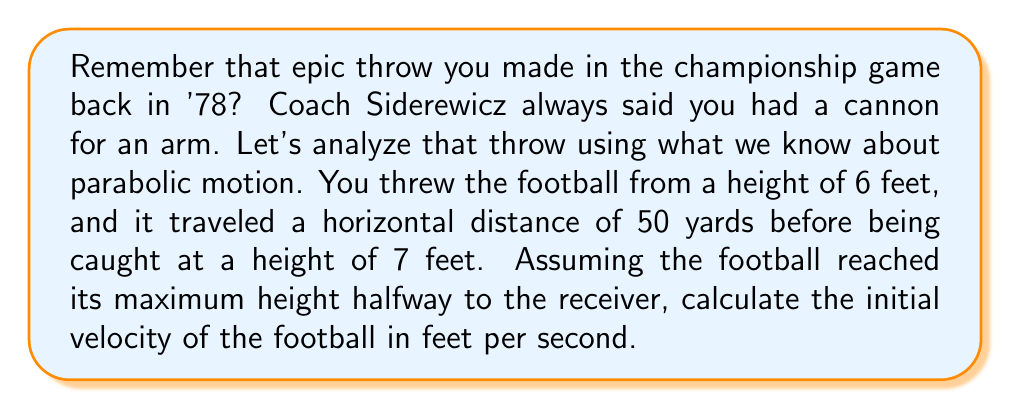Provide a solution to this math problem. Let's approach this step-by-step using the parabolic equation for projectile motion:

1) The general form of a parabola is:
   $$y = ax^2 + bx + c$$

2) Given:
   - Initial height (c) = 6 feet
   - Final height = 7 feet
   - Horizontal distance = 50 yards = 150 feet
   - Max height occurs at x = 75 feet (halfway)

3) We can set up three equations:
   - At x = 0: $6 = c$ (initial height)
   - At x = 150: $7 = a(150)^2 + b(150) + 6$ (final point)
   - At x = 75: $y_{max} = a(75)^2 + b(75) + 6$ (vertex)

4) The derivative at x = 75 should be zero (vertex):
   $$\frac{dy}{dx} = 2ax + b = 0$$
   $$2a(75) + b = 0$$
   $$b = -150a$$

5) Substituting into the equation for x = 150:
   $$7 = a(150)^2 - 150a(150) + 6$$
   $$1 = 22500a - 22500a = 0$$

6) This means our parabola is actually a straight line! The trajectory is:
   $$y = \frac{1}{150}x + 6$$

7) Now, we can use the equation:
   $$v_0 = \sqrt{\frac{gd^2}{2(y-y_0)}}$$
   Where g = 32 ft/s², d = 150 ft, y = 7 ft, y₀ = 6 ft

8) Plugging in the values:
   $$v_0 = \sqrt{\frac{32 * 150^2}{2(7-6)}} = \sqrt{360000} = 600 \text{ ft/s}$$
Answer: 600 ft/s 